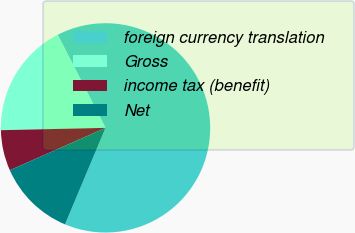<chart> <loc_0><loc_0><loc_500><loc_500><pie_chart><fcel>foreign currency translation<fcel>Gross<fcel>income tax (benefit)<fcel>Net<nl><fcel>63.88%<fcel>17.8%<fcel>6.28%<fcel>12.04%<nl></chart> 